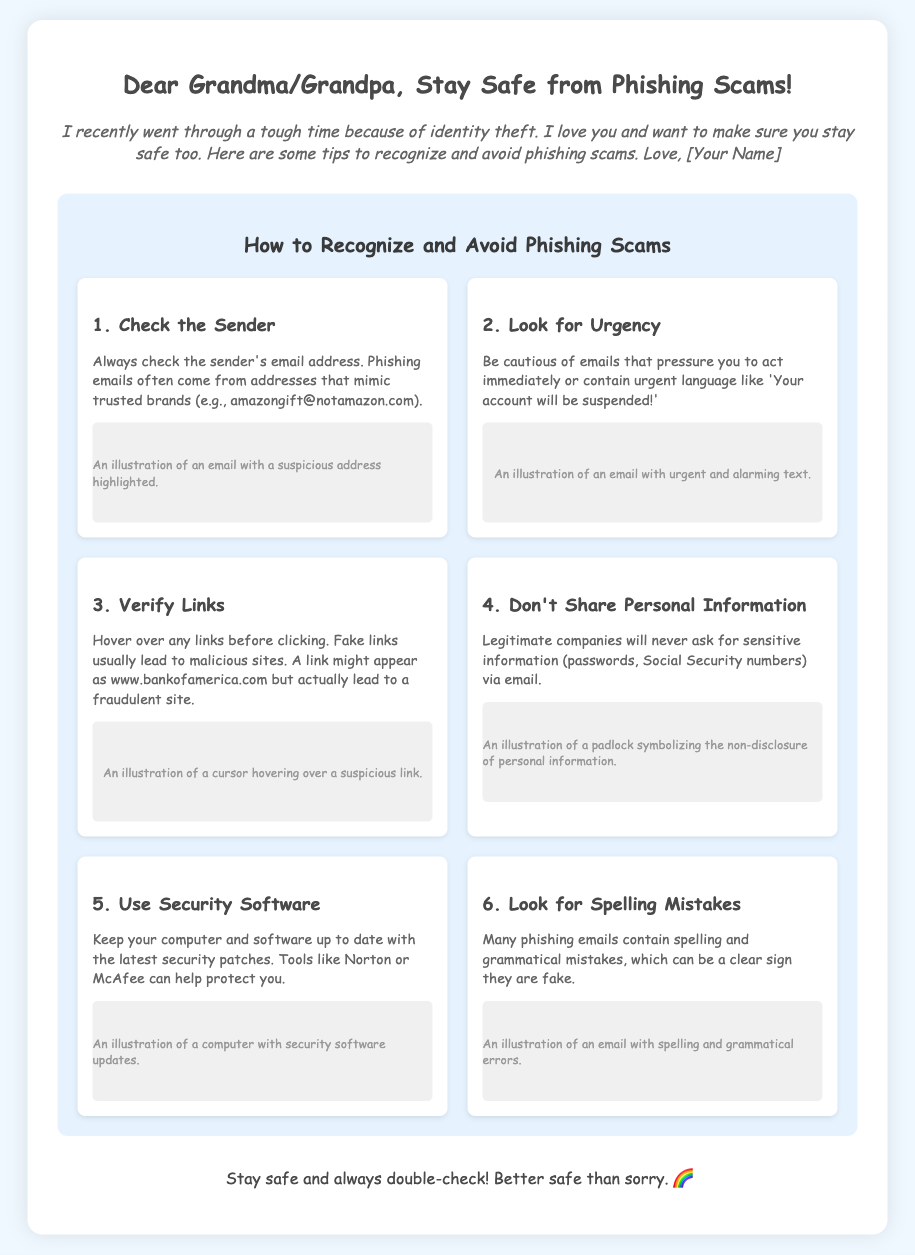What is the title of the card? The title is prominently displayed at the top of the card.
Answer: Stay Safe from Phishing Scams! Who is the card addressed to? The card begins with a greeting directed at the recipient.
Answer: Grandma/Grandpa How many steps are there to recognize and avoid phishing scams? The steps are listed in the infographic section.
Answer: Six What should you check about the sender? The step discusses an important aspect of email safety.
Answer: The sender's email address What type of mistakes may indicate a phishing scam? This is mentioned as a warning sign in the infographic.
Answer: Spelling and grammatical mistakes Is it safe to share sensitive information via email? The card explicitly advises against sharing certain information.
Answer: No 